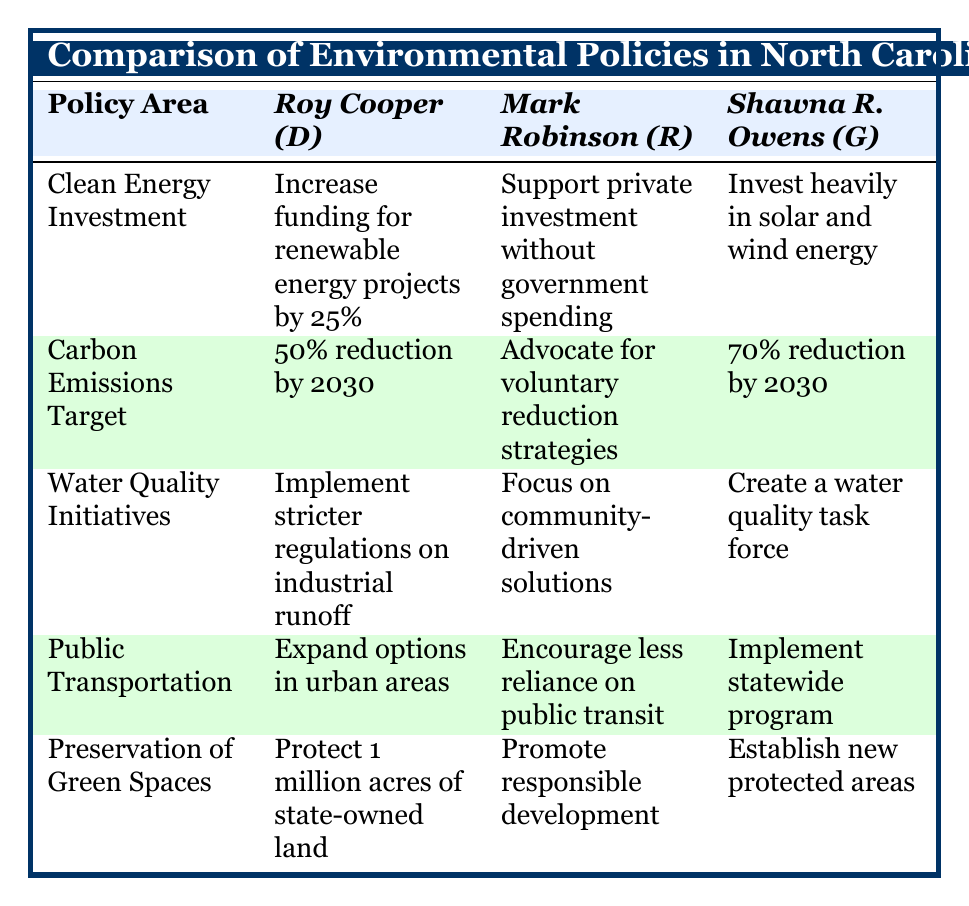What is Roy Cooper's target for carbon emissions reduction? The table shows that Roy Cooper aims for a 50% reduction in carbon emissions by 2030.
Answer: 50% reduction by 2030 Which candidate supports increasing funding for renewable energy projects? According to the table, Roy Cooper is the candidate who proposes to increase funding for renewable energy projects by 25%.
Answer: Roy Cooper True or False: Shawna R. Owens advocates for promoting responsible development rather than land preservation. The table indicates that Shawna R. Owens focuses on establishing new protected wildlife corridors and parks, so the statement is false.
Answer: False What is the difference in carbon emissions targets between Shawna R. Owens and Mark Robinson? Shawna R. Owens targets a 70% reduction while Mark Robinson advocates for voluntary strategies, which doesn't provide a specific percentage. Thus, the available difference is 70% (as a target) versus a lack of a defined goal. Since Mark Robinson's target is not quantitatively defined, we conclude there's a 70% clear target difference.
Answer: 70% difference (Owens has a specific target) Which candidate has proposed a solution for water quality that includes community representation? The table states that Shawna R. Owens proposes creating a water quality task force with diverse community representation.
Answer: Shawna R. Owens How do the candidates' policies on public transportation differ? Roy Cooper wants to expand public transit options, Mark Robinson encourages less reliance on public transit, and Shawna R. Owens plans to implement a statewide program. This showcases conflicting views on transit reliance and expansion.
Answer: They differ significantly: Cooper expands, Robinson reduces reliance, Owens enhances access 